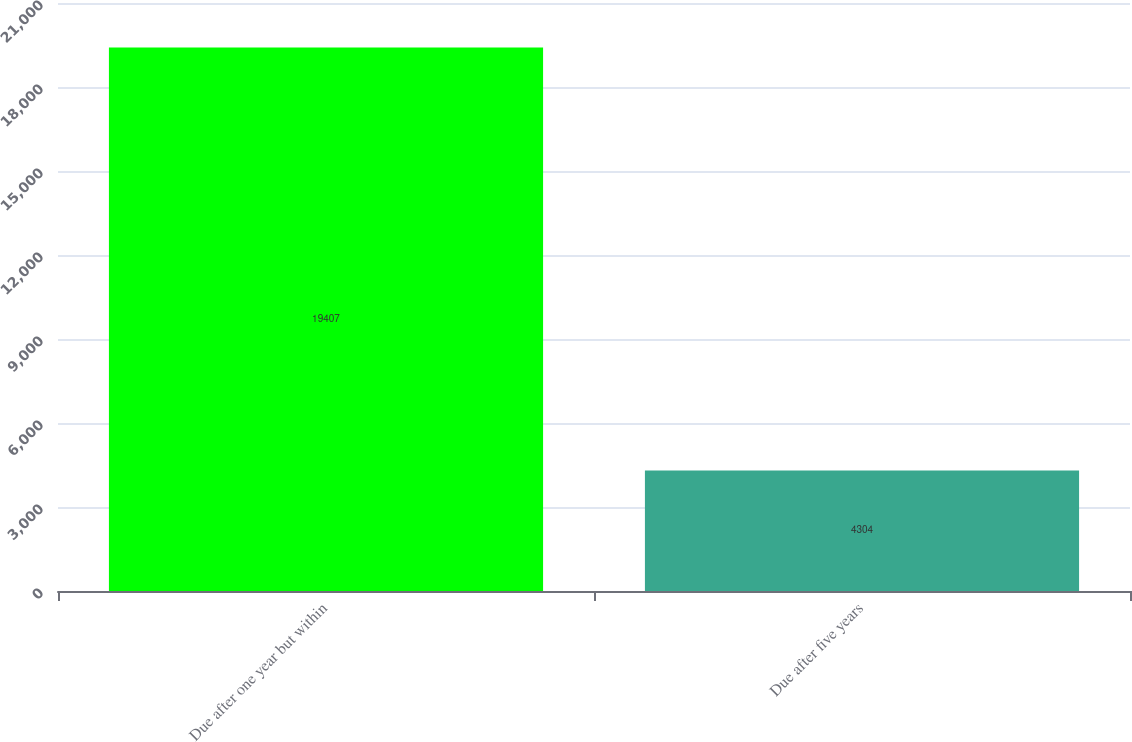<chart> <loc_0><loc_0><loc_500><loc_500><bar_chart><fcel>Due after one year but within<fcel>Due after five years<nl><fcel>19407<fcel>4304<nl></chart> 